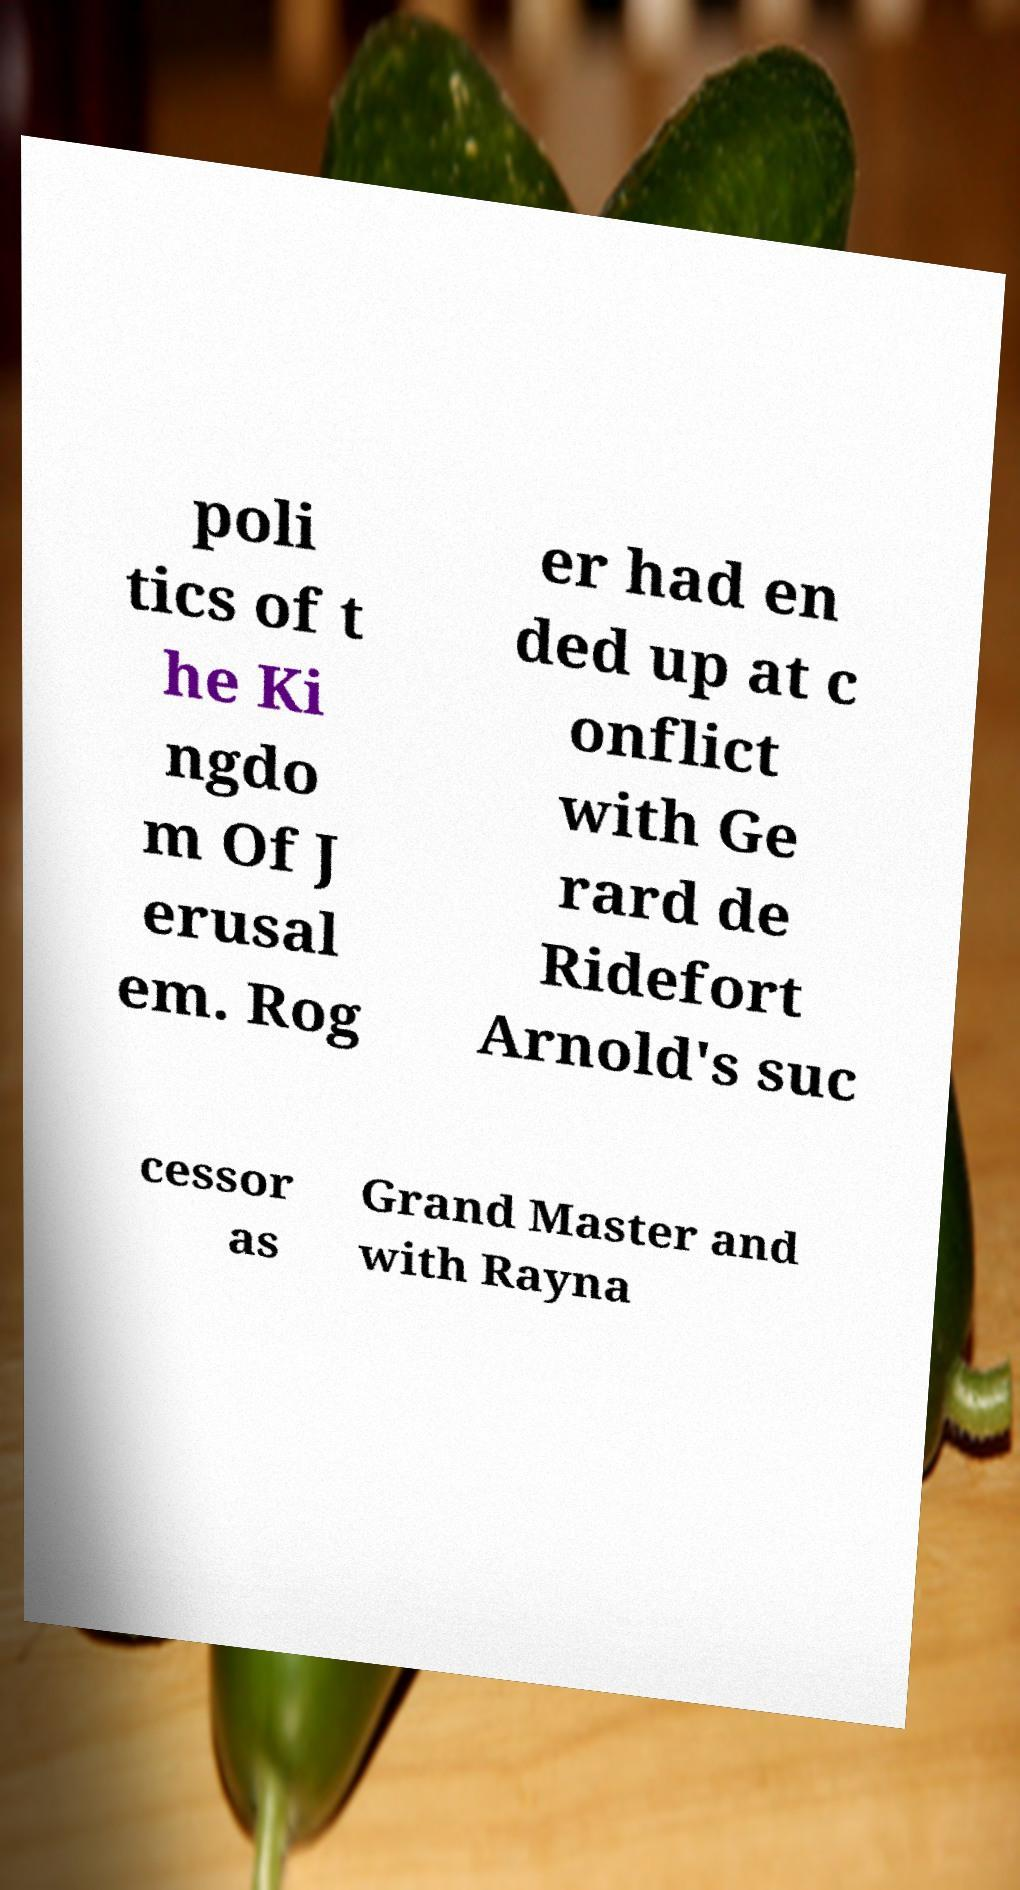For documentation purposes, I need the text within this image transcribed. Could you provide that? poli tics of t he Ki ngdo m Of J erusal em. Rog er had en ded up at c onflict with Ge rard de Ridefort Arnold's suc cessor as Grand Master and with Rayna 